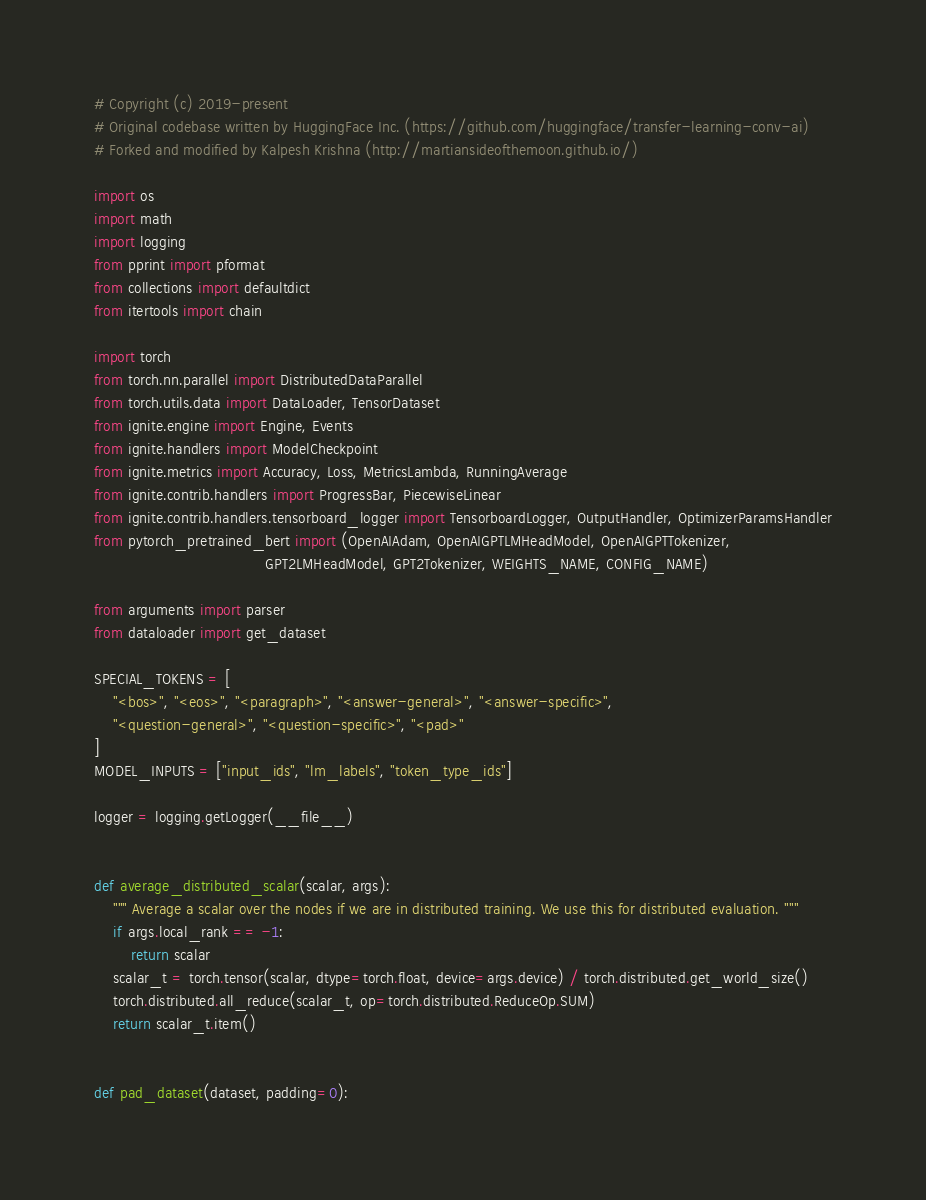<code> <loc_0><loc_0><loc_500><loc_500><_Python_># Copyright (c) 2019-present
# Original codebase written by HuggingFace Inc. (https://github.com/huggingface/transfer-learning-conv-ai)
# Forked and modified by Kalpesh Krishna (http://martiansideofthemoon.github.io/)

import os
import math
import logging
from pprint import pformat
from collections import defaultdict
from itertools import chain

import torch
from torch.nn.parallel import DistributedDataParallel
from torch.utils.data import DataLoader, TensorDataset
from ignite.engine import Engine, Events
from ignite.handlers import ModelCheckpoint
from ignite.metrics import Accuracy, Loss, MetricsLambda, RunningAverage
from ignite.contrib.handlers import ProgressBar, PiecewiseLinear
from ignite.contrib.handlers.tensorboard_logger import TensorboardLogger, OutputHandler, OptimizerParamsHandler
from pytorch_pretrained_bert import (OpenAIAdam, OpenAIGPTLMHeadModel, OpenAIGPTTokenizer,
                                     GPT2LMHeadModel, GPT2Tokenizer, WEIGHTS_NAME, CONFIG_NAME)

from arguments import parser
from dataloader import get_dataset

SPECIAL_TOKENS = [
    "<bos>", "<eos>", "<paragraph>", "<answer-general>", "<answer-specific>",
    "<question-general>", "<question-specific>", "<pad>"
]
MODEL_INPUTS = ["input_ids", "lm_labels", "token_type_ids"]

logger = logging.getLogger(__file__)


def average_distributed_scalar(scalar, args):
    """ Average a scalar over the nodes if we are in distributed training. We use this for distributed evaluation. """
    if args.local_rank == -1:
        return scalar
    scalar_t = torch.tensor(scalar, dtype=torch.float, device=args.device) / torch.distributed.get_world_size()
    torch.distributed.all_reduce(scalar_t, op=torch.distributed.ReduceOp.SUM)
    return scalar_t.item()


def pad_dataset(dataset, padding=0):</code> 